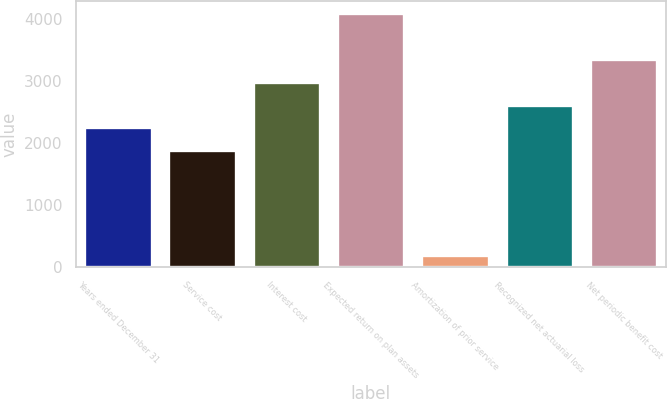Convert chart. <chart><loc_0><loc_0><loc_500><loc_500><bar_chart><fcel>Years ended December 31<fcel>Service cost<fcel>Interest cost<fcel>Expected return on plan assets<fcel>Amortization of prior service<fcel>Recognized net actuarial loss<fcel>Net periodic benefit cost<nl><fcel>2253.8<fcel>1886<fcel>2989.4<fcel>4092.8<fcel>196<fcel>2621.6<fcel>3357.2<nl></chart> 